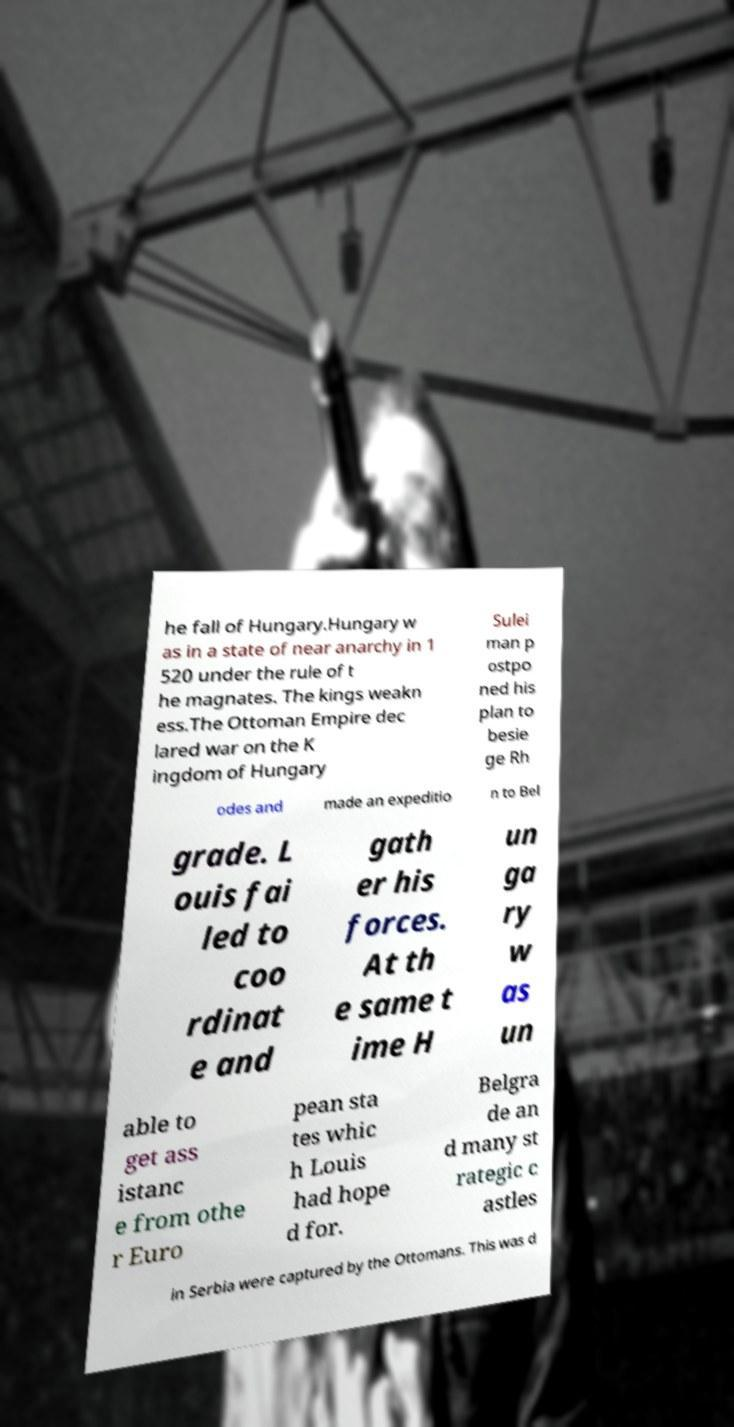For documentation purposes, I need the text within this image transcribed. Could you provide that? he fall of Hungary.Hungary w as in a state of near anarchy in 1 520 under the rule of t he magnates. The kings weakn ess.The Ottoman Empire dec lared war on the K ingdom of Hungary Sulei man p ostpo ned his plan to besie ge Rh odes and made an expeditio n to Bel grade. L ouis fai led to coo rdinat e and gath er his forces. At th e same t ime H un ga ry w as un able to get ass istanc e from othe r Euro pean sta tes whic h Louis had hope d for. Belgra de an d many st rategic c astles in Serbia were captured by the Ottomans. This was d 